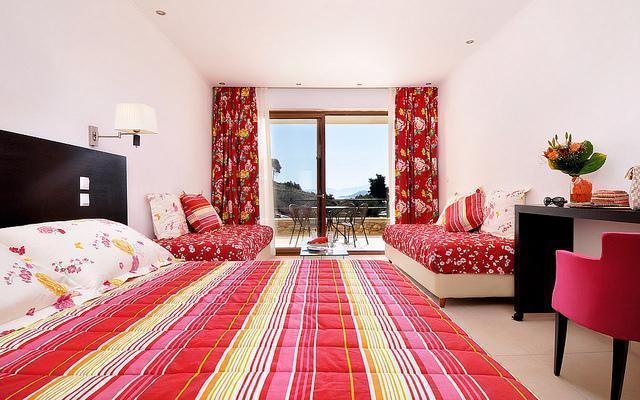How many beds are in the photo?
Give a very brief answer. 3. 